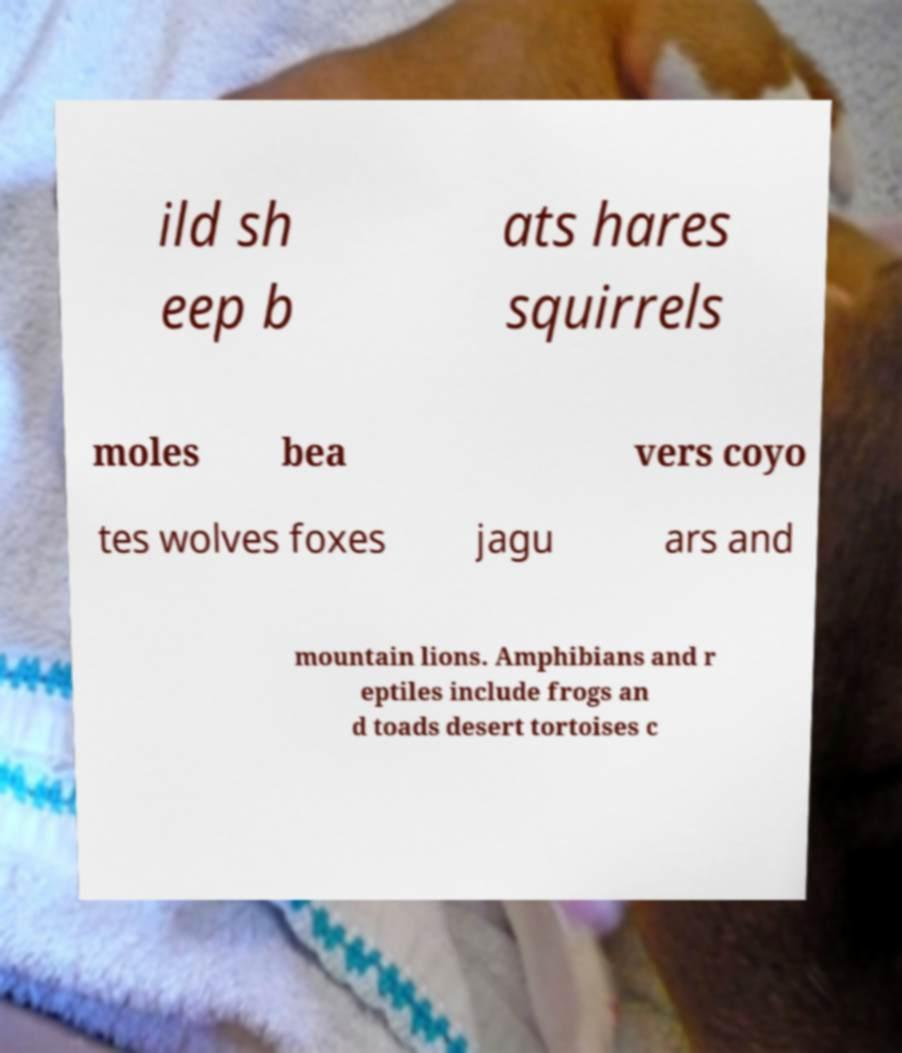Please identify and transcribe the text found in this image. ild sh eep b ats hares squirrels moles bea vers coyo tes wolves foxes jagu ars and mountain lions. Amphibians and r eptiles include frogs an d toads desert tortoises c 